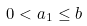Convert formula to latex. <formula><loc_0><loc_0><loc_500><loc_500>0 < a _ { 1 } \leq b</formula> 